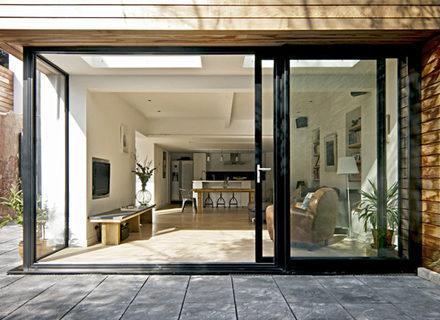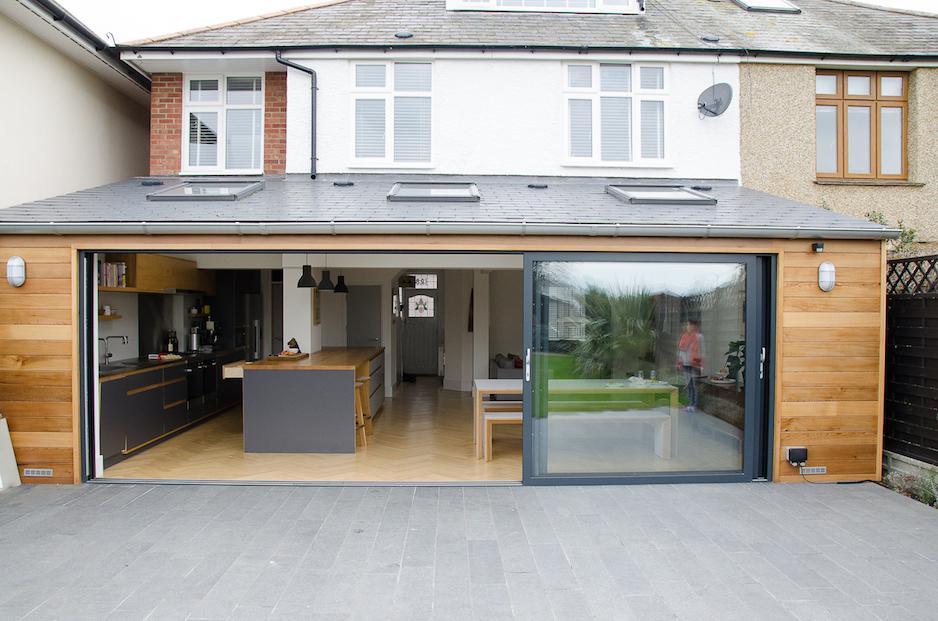The first image is the image on the left, the second image is the image on the right. For the images displayed, is the sentence "There are two exterior views of open glass panels that open to the outside." factually correct? Answer yes or no. Yes. The first image is the image on the left, the second image is the image on the right. Examine the images to the left and right. Is the description "At least one door has white trim." accurate? Answer yes or no. No. 